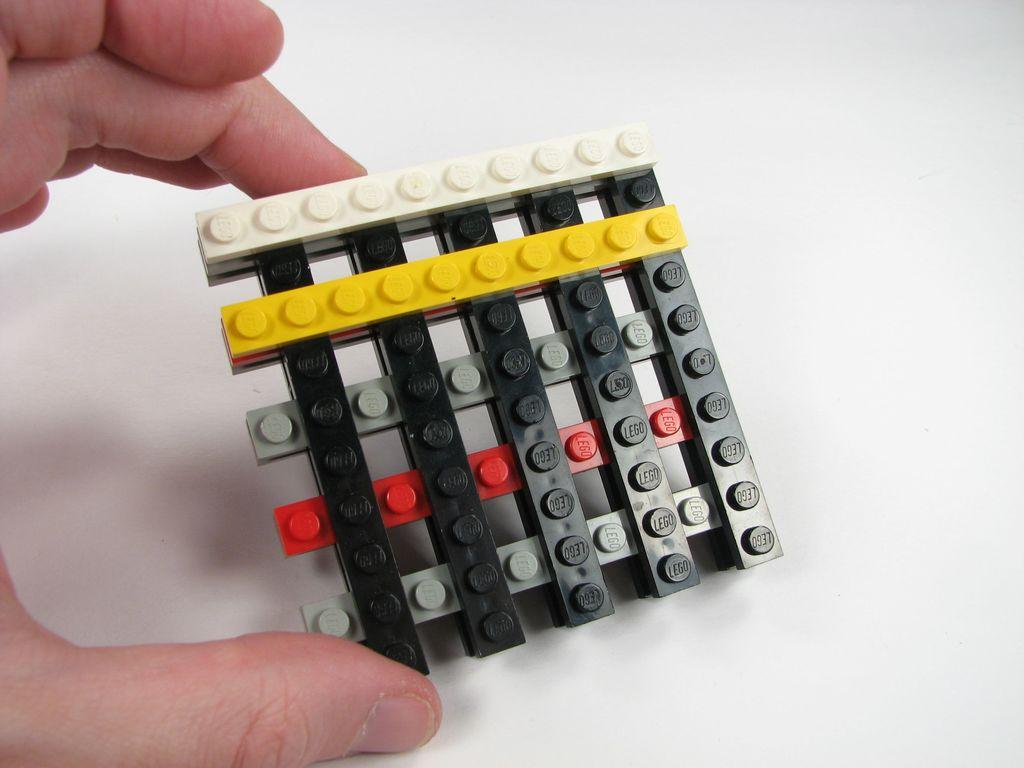What is the main object in the image? There is an interlocking block in the image. What is the color of the surface the block is on? The block is on a white surface. What type of picture is hanging on the wall behind the block in the image? There is no picture or wall visible in the image; it only shows an interlocking block on a white surface. 